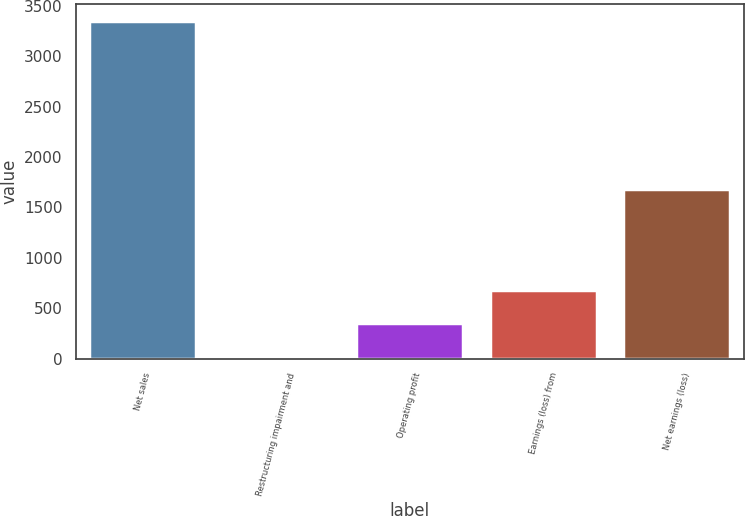Convert chart. <chart><loc_0><loc_0><loc_500><loc_500><bar_chart><fcel>Net sales<fcel>Restructuring impairment and<fcel>Operating profit<fcel>Earnings (loss) from<fcel>Net earnings (loss)<nl><fcel>3348<fcel>16<fcel>349.2<fcel>682.4<fcel>1682<nl></chart> 